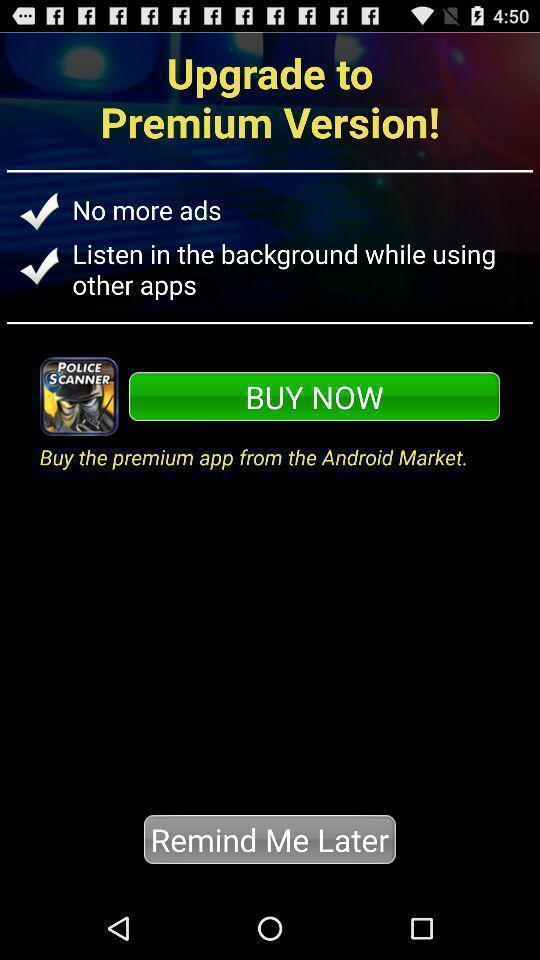Give me a narrative description of this picture. Page showing upgrade options in a police radio scanner app. 